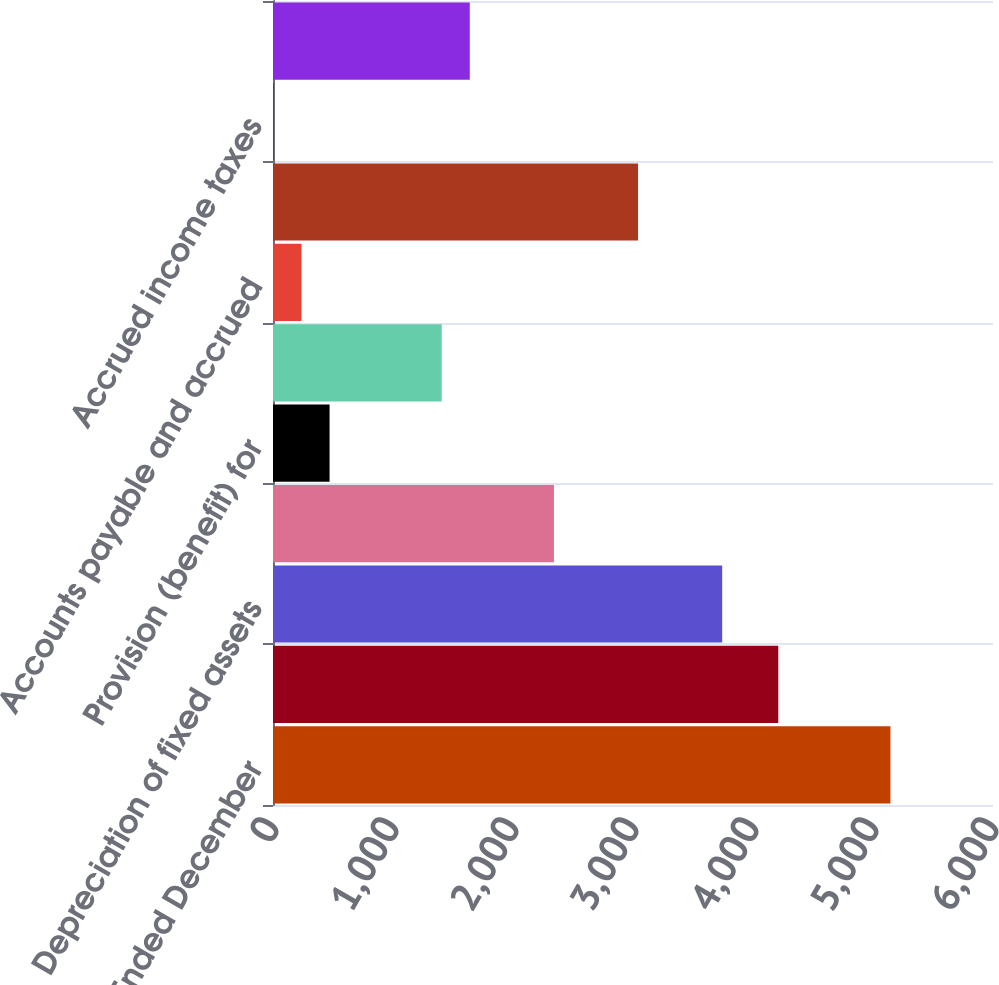Convert chart to OTSL. <chart><loc_0><loc_0><loc_500><loc_500><bar_chart><fcel>For the Years Ended December<fcel>Operating cash flows Net<fcel>Depreciation of fixed assets<fcel>Amortization of intangible<fcel>Provision (benefit) for<fcel>Changes in assets and<fcel>Accounts payable and accrued<fcel>Accrued compensation and<fcel>Accrued income taxes<fcel>Other liabilities<nl><fcel>5145.4<fcel>4210.6<fcel>3743.2<fcel>2341<fcel>471.4<fcel>1406.2<fcel>237.7<fcel>3042.1<fcel>4<fcel>1639.9<nl></chart> 